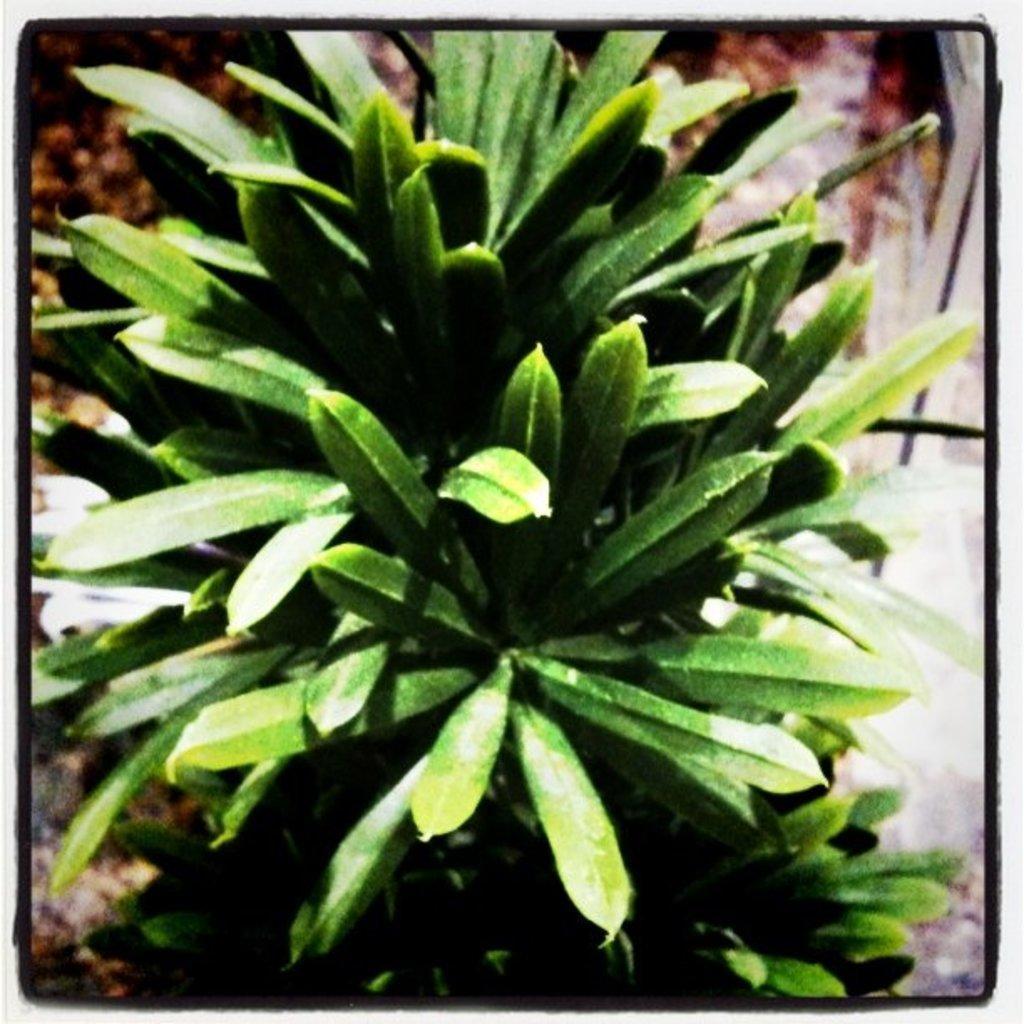Describe this image in one or two sentences. In this image I see the plant which is of green in color and I see that it is black on the borders. 